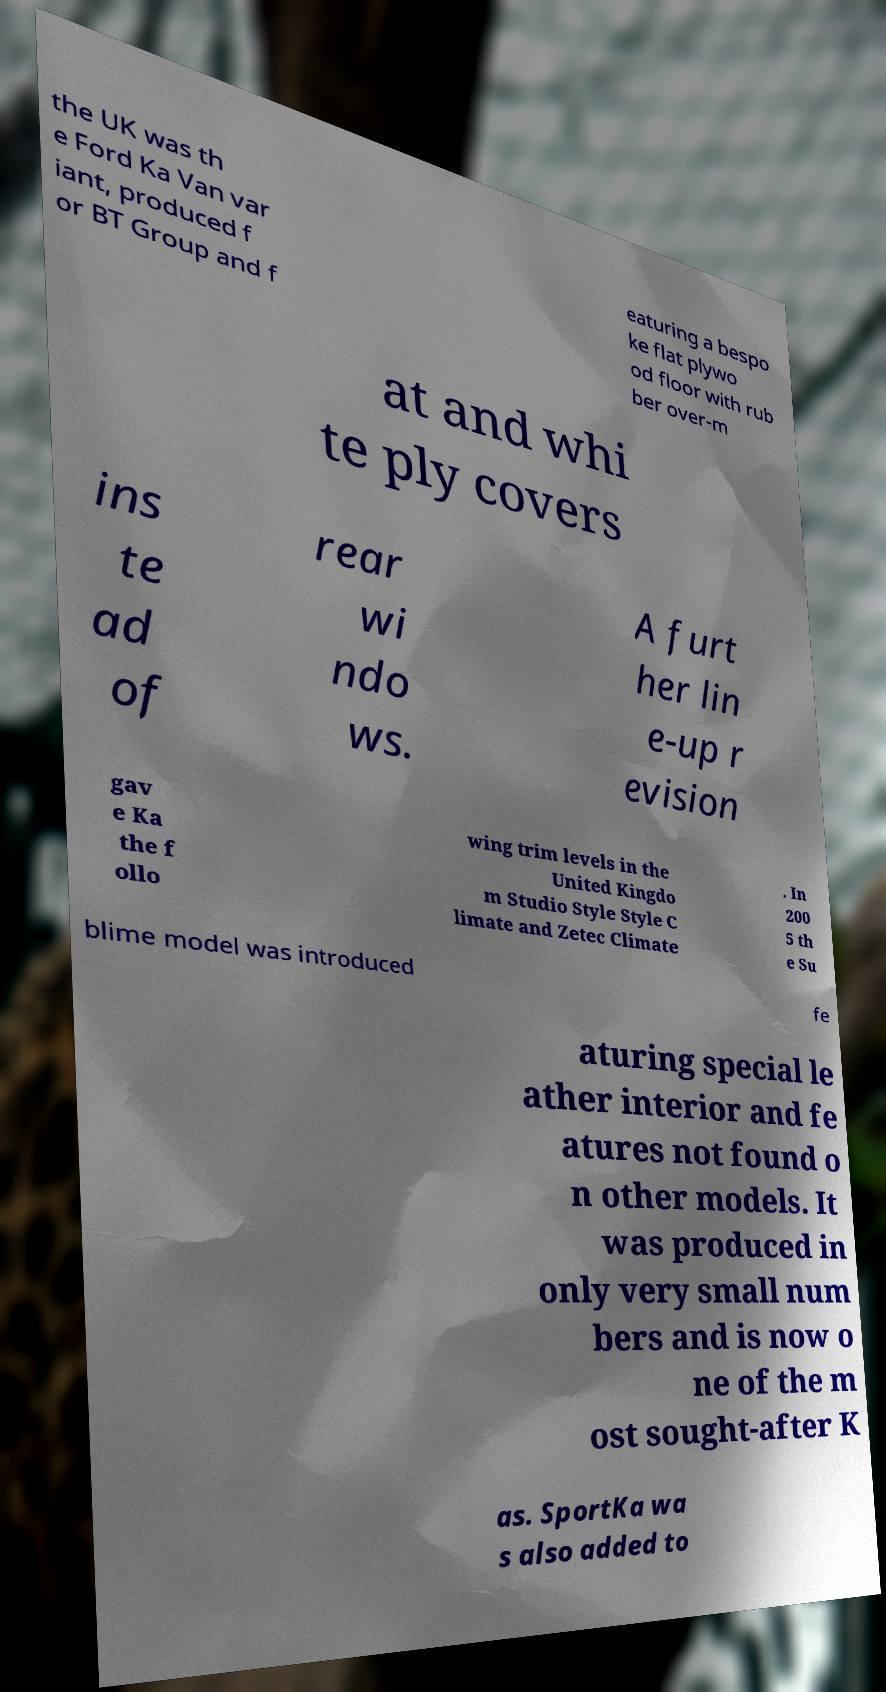Can you accurately transcribe the text from the provided image for me? the UK was th e Ford Ka Van var iant, produced f or BT Group and f eaturing a bespo ke flat plywo od floor with rub ber over-m at and whi te ply covers ins te ad of rear wi ndo ws. A furt her lin e-up r evision gav e Ka the f ollo wing trim levels in the United Kingdo m Studio Style Style C limate and Zetec Climate . In 200 5 th e Su blime model was introduced fe aturing special le ather interior and fe atures not found o n other models. It was produced in only very small num bers and is now o ne of the m ost sought-after K as. SportKa wa s also added to 